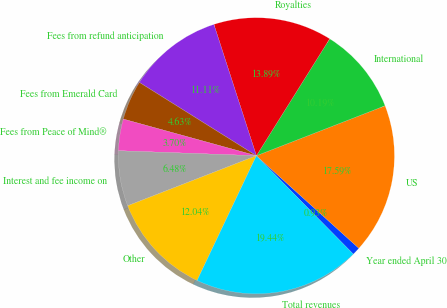<chart> <loc_0><loc_0><loc_500><loc_500><pie_chart><fcel>Year ended April 30<fcel>US<fcel>International<fcel>Royalties<fcel>Fees from refund anticipation<fcel>Fees from Emerald Card<fcel>Fees from Peace of Mind®<fcel>Interest and fee income on<fcel>Other<fcel>Total revenues<nl><fcel>0.93%<fcel>17.59%<fcel>10.19%<fcel>13.89%<fcel>11.11%<fcel>4.63%<fcel>3.7%<fcel>6.48%<fcel>12.04%<fcel>19.44%<nl></chart> 